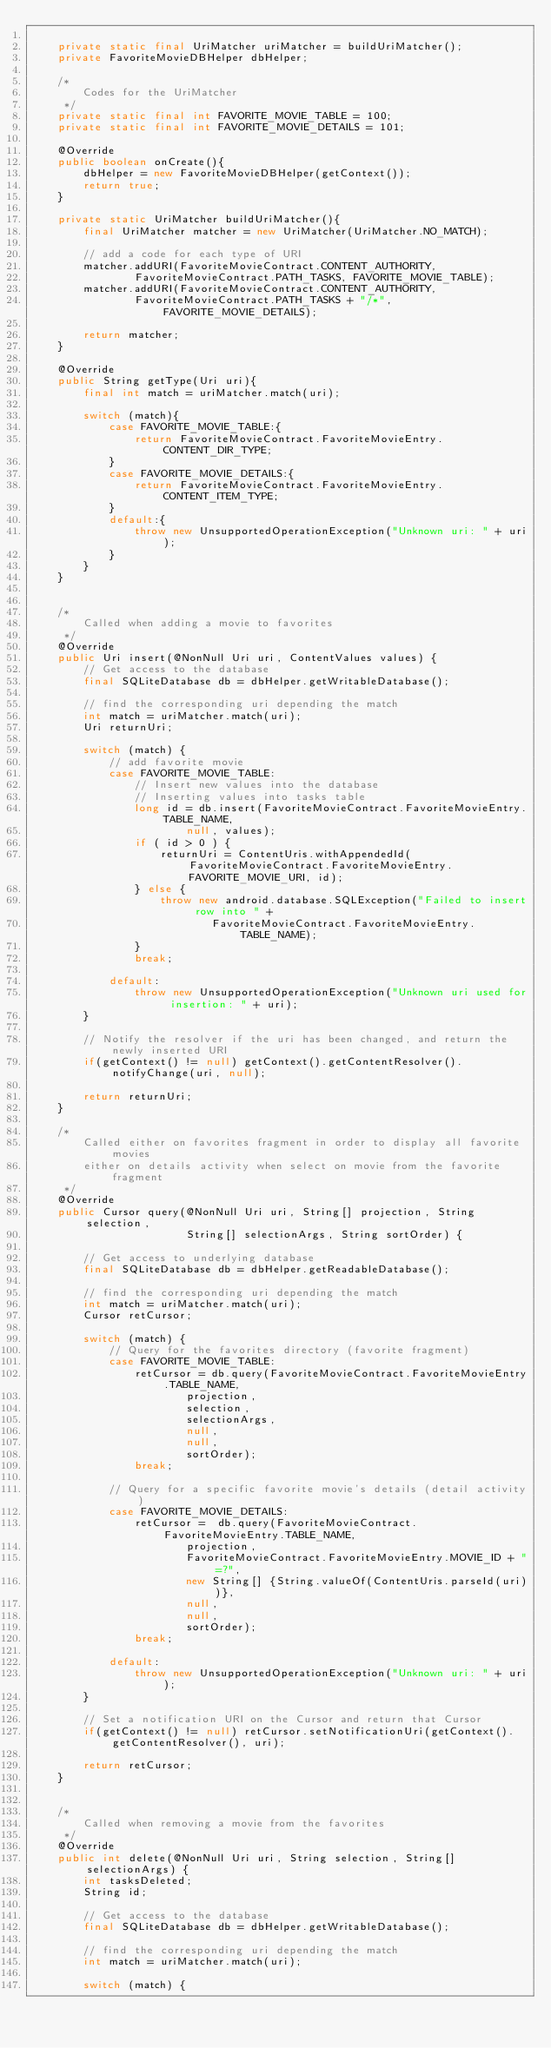Convert code to text. <code><loc_0><loc_0><loc_500><loc_500><_Java_>
    private static final UriMatcher uriMatcher = buildUriMatcher();
    private FavoriteMovieDBHelper dbHelper;

    /*
        Codes for the UriMatcher
     */
    private static final int FAVORITE_MOVIE_TABLE = 100;
    private static final int FAVORITE_MOVIE_DETAILS = 101;

    @Override
    public boolean onCreate(){
        dbHelper = new FavoriteMovieDBHelper(getContext());
        return true;
    }

    private static UriMatcher buildUriMatcher(){
        final UriMatcher matcher = new UriMatcher(UriMatcher.NO_MATCH);

        // add a code for each type of URI
        matcher.addURI(FavoriteMovieContract.CONTENT_AUTHORITY,
                FavoriteMovieContract.PATH_TASKS, FAVORITE_MOVIE_TABLE);
        matcher.addURI(FavoriteMovieContract.CONTENT_AUTHORITY,
                FavoriteMovieContract.PATH_TASKS + "/*", FAVORITE_MOVIE_DETAILS);

        return matcher;
    }

    @Override
    public String getType(Uri uri){
        final int match = uriMatcher.match(uri);

        switch (match){
            case FAVORITE_MOVIE_TABLE:{
                return FavoriteMovieContract.FavoriteMovieEntry.CONTENT_DIR_TYPE;
            }
            case FAVORITE_MOVIE_DETAILS:{
                return FavoriteMovieContract.FavoriteMovieEntry.CONTENT_ITEM_TYPE;
            }
            default:{
                throw new UnsupportedOperationException("Unknown uri: " + uri);
            }
        }
    }


    /*
        Called when adding a movie to favorites
     */
    @Override
    public Uri insert(@NonNull Uri uri, ContentValues values) {
        // Get access to the database
        final SQLiteDatabase db = dbHelper.getWritableDatabase();

        // find the corresponding uri depending the match
        int match = uriMatcher.match(uri);
        Uri returnUri;

        switch (match) {
            // add favorite movie
            case FAVORITE_MOVIE_TABLE:
                // Insert new values into the database
                // Inserting values into tasks table
                long id = db.insert(FavoriteMovieContract.FavoriteMovieEntry.TABLE_NAME,
                        null, values);
                if ( id > 0 ) {
                    returnUri = ContentUris.withAppendedId(FavoriteMovieContract.FavoriteMovieEntry.FAVORITE_MOVIE_URI, id);
                } else {
                    throw new android.database.SQLException("Failed to insert row into " +
                            FavoriteMovieContract.FavoriteMovieEntry.TABLE_NAME);
                }
                break;

            default:
                throw new UnsupportedOperationException("Unknown uri used for insertion: " + uri);
        }

        // Notify the resolver if the uri has been changed, and return the newly inserted URI
        if(getContext() != null) getContext().getContentResolver().notifyChange(uri, null);

        return returnUri;
    }

    /*
        Called either on favorites fragment in order to display all favorite movies
        either on details activity when select on movie from the favorite fragment
     */
    @Override
    public Cursor query(@NonNull Uri uri, String[] projection, String selection,
                        String[] selectionArgs, String sortOrder) {

        // Get access to underlying database
        final SQLiteDatabase db = dbHelper.getReadableDatabase();

        // find the corresponding uri depending the match
        int match = uriMatcher.match(uri);
        Cursor retCursor;

        switch (match) {
            // Query for the favorites directory (favorite fragment)
            case FAVORITE_MOVIE_TABLE:
                retCursor = db.query(FavoriteMovieContract.FavoriteMovieEntry.TABLE_NAME,
                        projection,
                        selection,
                        selectionArgs,
                        null,
                        null,
                        sortOrder);
                break;

            // Query for a specific favorite movie's details (detail activity)
            case FAVORITE_MOVIE_DETAILS:
                retCursor =  db.query(FavoriteMovieContract.FavoriteMovieEntry.TABLE_NAME,
                        projection,
                        FavoriteMovieContract.FavoriteMovieEntry.MOVIE_ID + "=?",
                        new String[] {String.valueOf(ContentUris.parseId(uri))},
                        null,
                        null,
                        sortOrder);
                break;

            default:
                throw new UnsupportedOperationException("Unknown uri: " + uri);
        }

        // Set a notification URI on the Cursor and return that Cursor
        if(getContext() != null) retCursor.setNotificationUri(getContext().getContentResolver(), uri);

        return retCursor;
    }


    /*
        Called when removing a movie from the favorites
     */
    @Override
    public int delete(@NonNull Uri uri, String selection, String[] selectionArgs) {
        int tasksDeleted;
        String id;

        // Get access to the database
        final SQLiteDatabase db = dbHelper.getWritableDatabase();

        // find the corresponding uri depending the match
        int match = uriMatcher.match(uri);

        switch (match) {</code> 